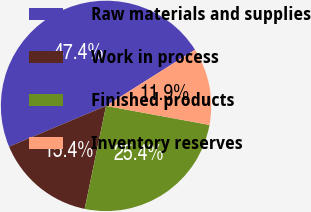Convert chart. <chart><loc_0><loc_0><loc_500><loc_500><pie_chart><fcel>Raw materials and supplies<fcel>Work in process<fcel>Finished products<fcel>Inventory reserves<nl><fcel>47.36%<fcel>15.41%<fcel>25.36%<fcel>11.86%<nl></chart> 